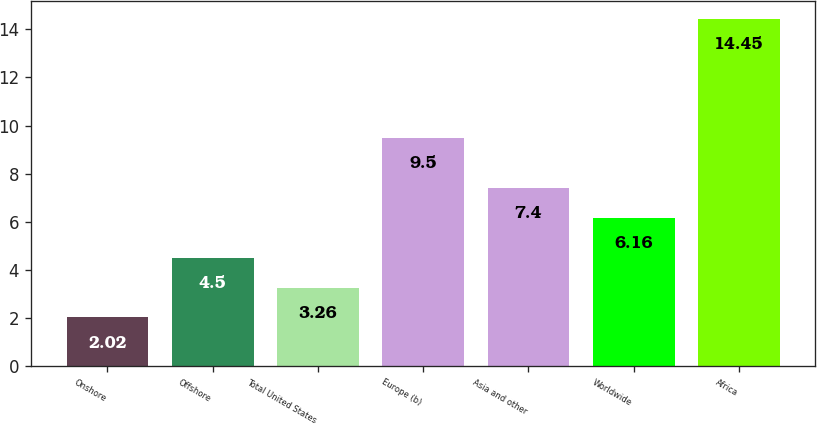Convert chart. <chart><loc_0><loc_0><loc_500><loc_500><bar_chart><fcel>Onshore<fcel>Offshore<fcel>Total United States<fcel>Europe (b)<fcel>Asia and other<fcel>Worldwide<fcel>Africa<nl><fcel>2.02<fcel>4.5<fcel>3.26<fcel>9.5<fcel>7.4<fcel>6.16<fcel>14.45<nl></chart> 